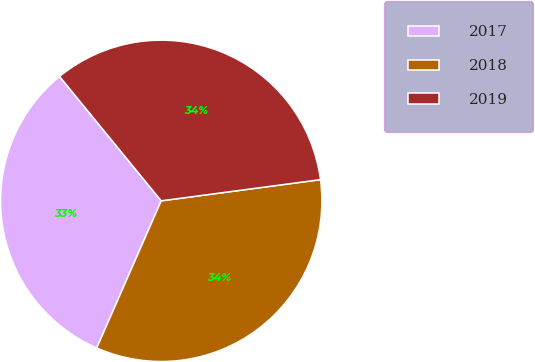<chart> <loc_0><loc_0><loc_500><loc_500><pie_chart><fcel>2017<fcel>2018<fcel>2019<nl><fcel>32.52%<fcel>33.68%<fcel>33.8%<nl></chart> 